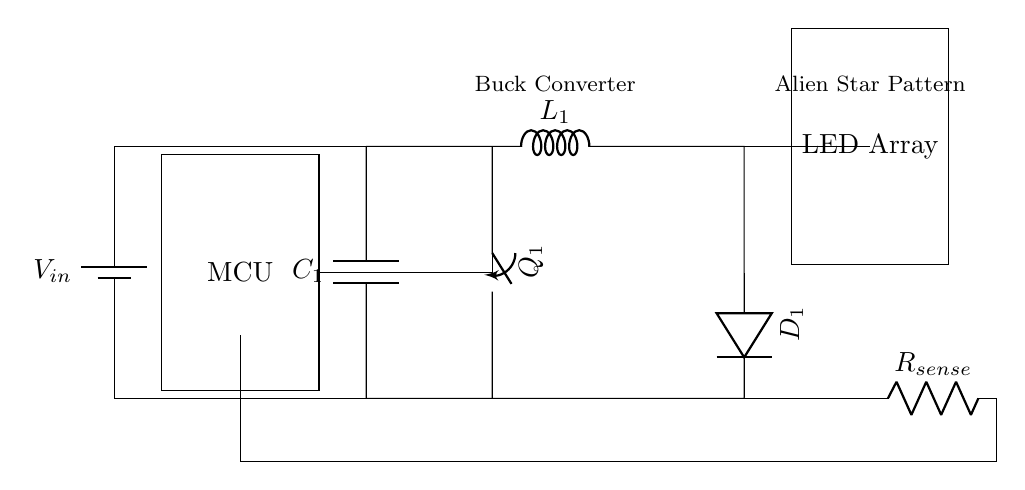What component converts the input voltage? The component responsible for converting the input voltage is the buck converter. It steps down the voltage from the power supply to a lower level suitable for the LED array.
Answer: buck converter What is the purpose of the current sense resistor? The current sense resistor is used to measure the current flowing through the LED array. By measuring the voltage across it, the MCU can determine how much current is being drawn, allowing for adjustments to maintain efficiency.
Answer: measure current Which component controls the switching of the buck converter? The component that controls the switching of the buck converter is the switch labeled Q1. It is part of the buck converter circuit that helps regulate output voltage by turning on and off in response to control signals.
Answer: Q1 What is the role of the microcontroller in this circuit? The microcontroller monitors and controls the operation of the buck converter, adjusting the output voltage and current to achieve the desired lighting effects in the LED array for simulating star patterns.
Answer: control operation How is the LED array powered in this circuit? The LED array is powered through the output of the buck converter, which converts the input voltage to the required voltage and current levels needed for the LED array to function properly.
Answer: buck converter output How does the circuit maintain energy efficiency? The circuit maintains energy efficiency by using a buck converter to reduce voltage loss and a microcontroller that optimizes the current flow to the LED array based on real-time measurements, minimizing energy waste.
Answer: optimization techniques 